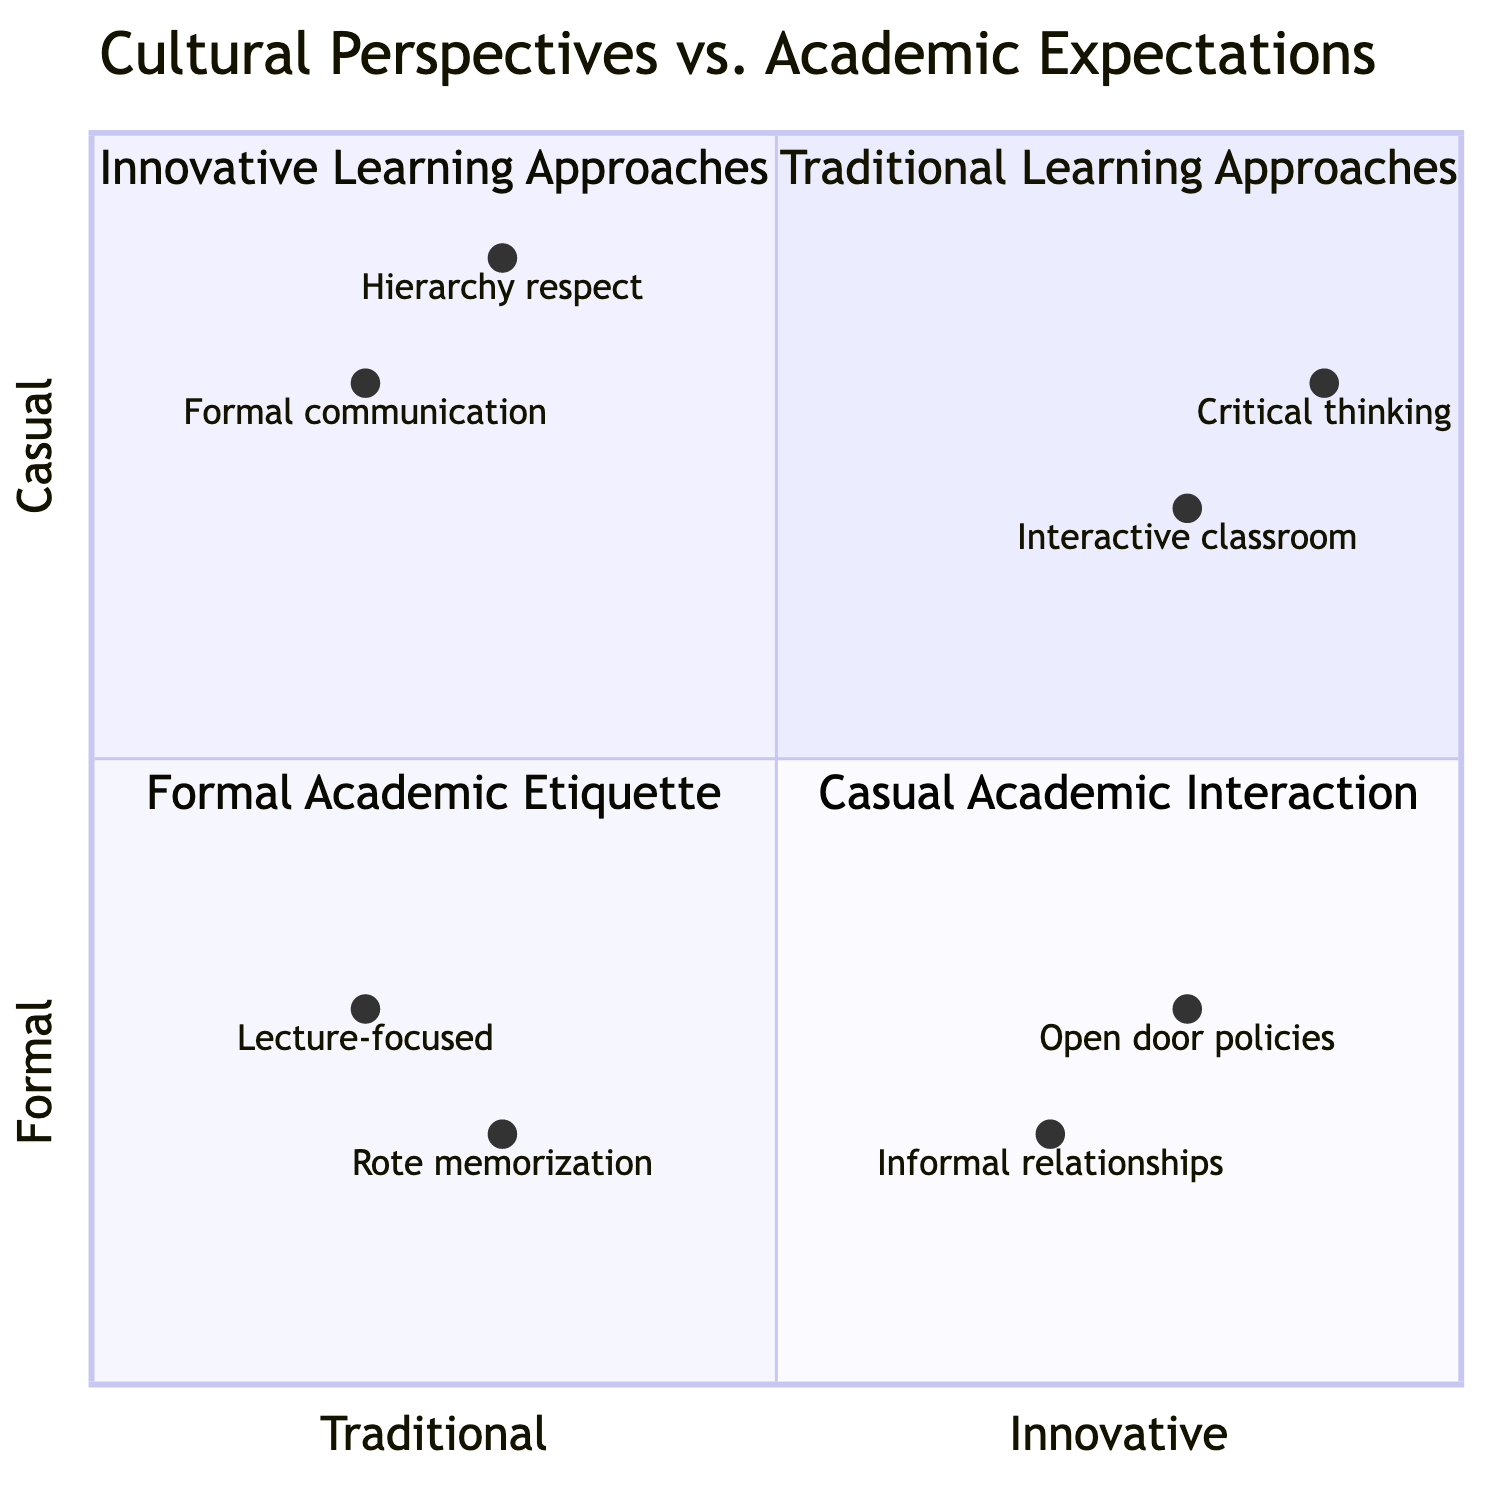What is in the top-left quadrant? The top-left quadrant represents "Traditional Learning Approaches," which includes elements like "Lecture-focused classroom" and "High emphasis on rote memorization".
Answer: Traditional Learning Approaches What is the x-axis label? The x-axis label is "Traditional --> Innovative," indicating the spectrum from traditional to innovative approaches in education.
Answer: Traditional --> Innovative Which quadrant contains "Interactive and participatory classroom"? The element "Interactive and participatory classroom" is located in the second quadrant, labeled "Innovative Learning Approaches".
Answer: Innovative Learning Approaches How many elements are in the "Formal Academic Etiquette" quadrant? The "Formal Academic Etiquette" quadrant contains two elements: "Strict adherence to formal communication" and "Respect for hierarchy in academic settings".
Answer: 2 Which quadrant is associated with "Open door policies"? The element "Open door policies" is found in the fourth quadrant, labeled "Casual Academic Interaction".
Answer: Casual Academic Interaction Which element is closest to the coordinate [0.9, 0.8]? The element closest to the coordinate [0.9, 0.8] is "Critical thinking and problem-solving skills," located in the "Innovative Learning Approaches" quadrant.
Answer: Critical thinking What can be inferred about the relationship between "Lecture-focused classroom" and "Interactive classroom"? "Lecture-focused classroom" is in the top-left quadrant, while "Interactive classroom" is in the top-right quadrant, indicating a shift from traditional to innovative methods.
Answer: Shift from traditional to innovative Which element is located at coordinate [0.3, 0.2]? The element located at coordinate [0.3, 0.2] is "Rote memorization," which is a traditional learning approach.
Answer: Rote memorization 